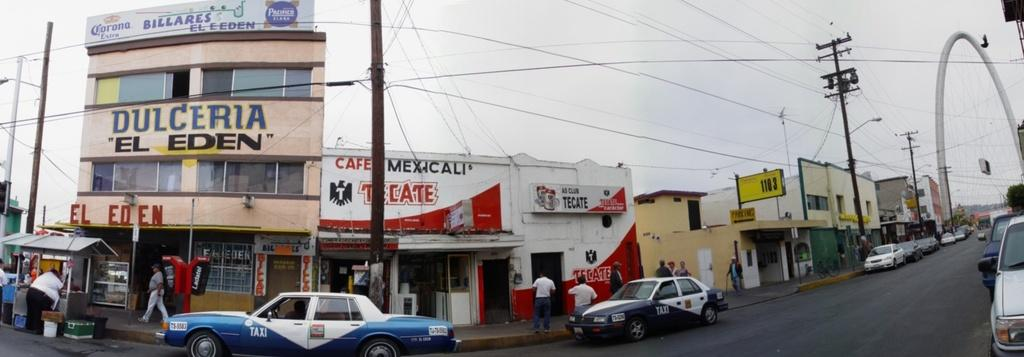<image>
Write a terse but informative summary of the picture. A street scene with a building that has the words Dliceria El Eden on the front. 